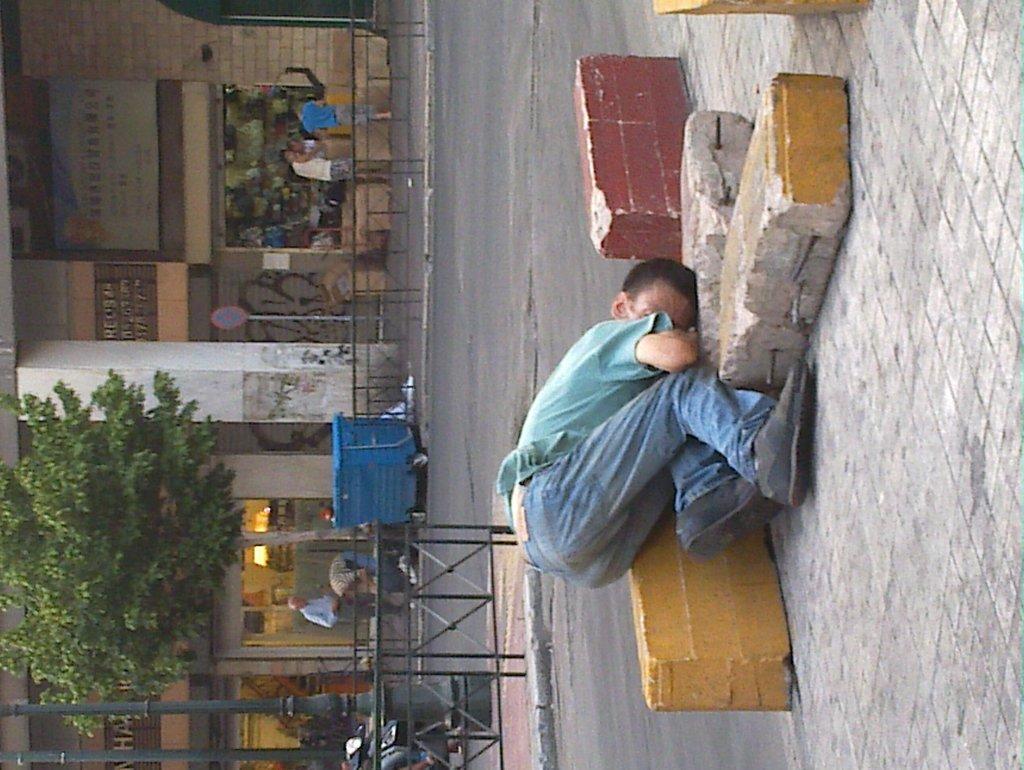Describe this image in one or two sentences. In this image person is lying on the road. At the back side there are trees, buildings, sign board. There are few people standing in front of the building. At the left side of the image there is a metal grill. 